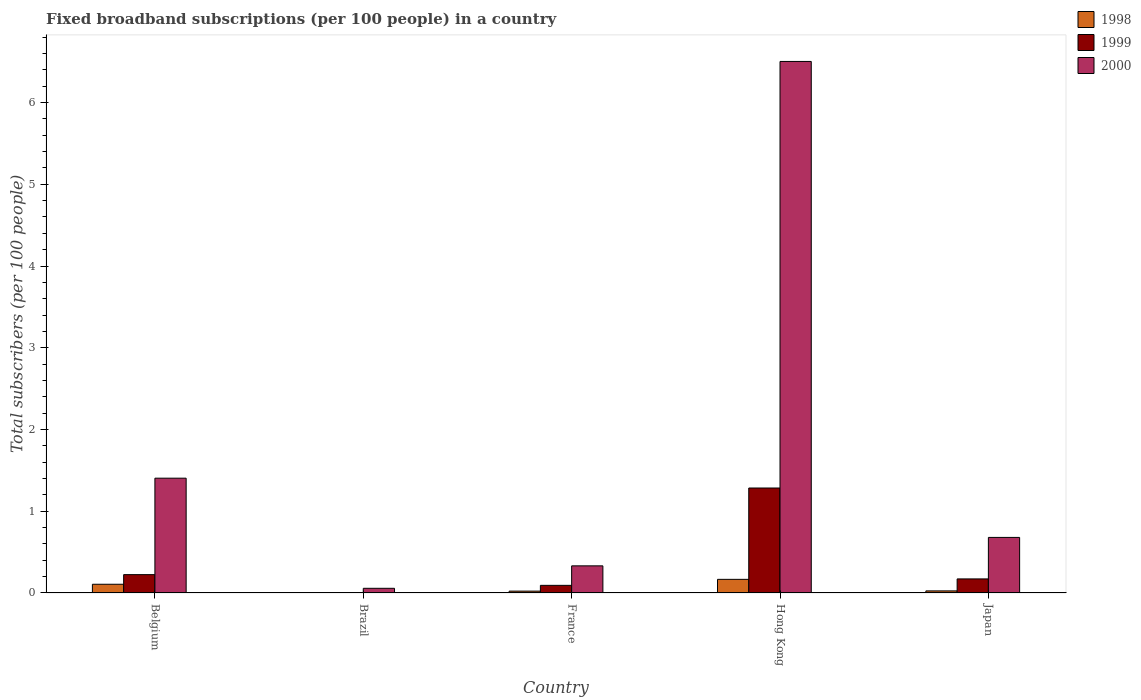Are the number of bars on each tick of the X-axis equal?
Your response must be concise. Yes. How many bars are there on the 2nd tick from the right?
Provide a short and direct response. 3. What is the label of the 4th group of bars from the left?
Provide a succinct answer. Hong Kong. What is the number of broadband subscriptions in 1999 in Brazil?
Make the answer very short. 0. Across all countries, what is the maximum number of broadband subscriptions in 2000?
Ensure brevity in your answer.  6.5. Across all countries, what is the minimum number of broadband subscriptions in 1999?
Keep it short and to the point. 0. In which country was the number of broadband subscriptions in 2000 maximum?
Keep it short and to the point. Hong Kong. What is the total number of broadband subscriptions in 1999 in the graph?
Offer a terse response. 1.78. What is the difference between the number of broadband subscriptions in 2000 in Belgium and that in Brazil?
Your answer should be compact. 1.35. What is the difference between the number of broadband subscriptions in 1998 in Brazil and the number of broadband subscriptions in 2000 in Hong Kong?
Keep it short and to the point. -6.5. What is the average number of broadband subscriptions in 1999 per country?
Offer a terse response. 0.36. What is the difference between the number of broadband subscriptions of/in 1999 and number of broadband subscriptions of/in 2000 in Japan?
Keep it short and to the point. -0.51. What is the ratio of the number of broadband subscriptions in 1999 in Belgium to that in France?
Your answer should be very brief. 2.4. What is the difference between the highest and the second highest number of broadband subscriptions in 1998?
Provide a short and direct response. 0.06. What is the difference between the highest and the lowest number of broadband subscriptions in 1999?
Your response must be concise. 1.28. In how many countries, is the number of broadband subscriptions in 1998 greater than the average number of broadband subscriptions in 1998 taken over all countries?
Make the answer very short. 2. Is the sum of the number of broadband subscriptions in 1999 in France and Hong Kong greater than the maximum number of broadband subscriptions in 2000 across all countries?
Give a very brief answer. No. What does the 1st bar from the right in Brazil represents?
Provide a succinct answer. 2000. How many bars are there?
Your answer should be very brief. 15. Are all the bars in the graph horizontal?
Offer a very short reply. No. How many countries are there in the graph?
Give a very brief answer. 5. What is the difference between two consecutive major ticks on the Y-axis?
Make the answer very short. 1. Does the graph contain any zero values?
Make the answer very short. No. Does the graph contain grids?
Make the answer very short. No. How many legend labels are there?
Make the answer very short. 3. What is the title of the graph?
Ensure brevity in your answer.  Fixed broadband subscriptions (per 100 people) in a country. What is the label or title of the Y-axis?
Keep it short and to the point. Total subscribers (per 100 people). What is the Total subscribers (per 100 people) in 1998 in Belgium?
Your answer should be compact. 0.11. What is the Total subscribers (per 100 people) of 1999 in Belgium?
Your answer should be compact. 0.22. What is the Total subscribers (per 100 people) in 2000 in Belgium?
Give a very brief answer. 1.4. What is the Total subscribers (per 100 people) in 1998 in Brazil?
Make the answer very short. 0. What is the Total subscribers (per 100 people) in 1999 in Brazil?
Your answer should be very brief. 0. What is the Total subscribers (per 100 people) of 2000 in Brazil?
Make the answer very short. 0.06. What is the Total subscribers (per 100 people) in 1998 in France?
Your response must be concise. 0.02. What is the Total subscribers (per 100 people) of 1999 in France?
Keep it short and to the point. 0.09. What is the Total subscribers (per 100 people) in 2000 in France?
Offer a terse response. 0.33. What is the Total subscribers (per 100 people) in 1998 in Hong Kong?
Your answer should be very brief. 0.17. What is the Total subscribers (per 100 people) in 1999 in Hong Kong?
Ensure brevity in your answer.  1.28. What is the Total subscribers (per 100 people) of 2000 in Hong Kong?
Provide a succinct answer. 6.5. What is the Total subscribers (per 100 people) of 1998 in Japan?
Offer a very short reply. 0.03. What is the Total subscribers (per 100 people) of 1999 in Japan?
Keep it short and to the point. 0.17. What is the Total subscribers (per 100 people) in 2000 in Japan?
Your response must be concise. 0.68. Across all countries, what is the maximum Total subscribers (per 100 people) of 1998?
Ensure brevity in your answer.  0.17. Across all countries, what is the maximum Total subscribers (per 100 people) in 1999?
Your answer should be very brief. 1.28. Across all countries, what is the maximum Total subscribers (per 100 people) of 2000?
Ensure brevity in your answer.  6.5. Across all countries, what is the minimum Total subscribers (per 100 people) of 1998?
Your response must be concise. 0. Across all countries, what is the minimum Total subscribers (per 100 people) in 1999?
Your answer should be compact. 0. Across all countries, what is the minimum Total subscribers (per 100 people) of 2000?
Your response must be concise. 0.06. What is the total Total subscribers (per 100 people) in 1998 in the graph?
Offer a terse response. 0.32. What is the total Total subscribers (per 100 people) in 1999 in the graph?
Provide a short and direct response. 1.78. What is the total Total subscribers (per 100 people) in 2000 in the graph?
Your answer should be very brief. 8.98. What is the difference between the Total subscribers (per 100 people) of 1998 in Belgium and that in Brazil?
Offer a terse response. 0.11. What is the difference between the Total subscribers (per 100 people) of 1999 in Belgium and that in Brazil?
Provide a succinct answer. 0.22. What is the difference between the Total subscribers (per 100 people) of 2000 in Belgium and that in Brazil?
Keep it short and to the point. 1.35. What is the difference between the Total subscribers (per 100 people) in 1998 in Belgium and that in France?
Offer a terse response. 0.08. What is the difference between the Total subscribers (per 100 people) of 1999 in Belgium and that in France?
Offer a very short reply. 0.13. What is the difference between the Total subscribers (per 100 people) of 2000 in Belgium and that in France?
Give a very brief answer. 1.07. What is the difference between the Total subscribers (per 100 people) in 1998 in Belgium and that in Hong Kong?
Your answer should be very brief. -0.06. What is the difference between the Total subscribers (per 100 people) in 1999 in Belgium and that in Hong Kong?
Give a very brief answer. -1.06. What is the difference between the Total subscribers (per 100 people) of 2000 in Belgium and that in Hong Kong?
Provide a short and direct response. -5.1. What is the difference between the Total subscribers (per 100 people) in 1998 in Belgium and that in Japan?
Offer a terse response. 0.08. What is the difference between the Total subscribers (per 100 people) in 1999 in Belgium and that in Japan?
Ensure brevity in your answer.  0.05. What is the difference between the Total subscribers (per 100 people) in 2000 in Belgium and that in Japan?
Your answer should be compact. 0.72. What is the difference between the Total subscribers (per 100 people) in 1998 in Brazil and that in France?
Give a very brief answer. -0.02. What is the difference between the Total subscribers (per 100 people) of 1999 in Brazil and that in France?
Make the answer very short. -0.09. What is the difference between the Total subscribers (per 100 people) of 2000 in Brazil and that in France?
Offer a terse response. -0.27. What is the difference between the Total subscribers (per 100 people) of 1998 in Brazil and that in Hong Kong?
Provide a succinct answer. -0.17. What is the difference between the Total subscribers (per 100 people) in 1999 in Brazil and that in Hong Kong?
Keep it short and to the point. -1.28. What is the difference between the Total subscribers (per 100 people) in 2000 in Brazil and that in Hong Kong?
Keep it short and to the point. -6.45. What is the difference between the Total subscribers (per 100 people) in 1998 in Brazil and that in Japan?
Your answer should be compact. -0.03. What is the difference between the Total subscribers (per 100 people) in 1999 in Brazil and that in Japan?
Make the answer very short. -0.17. What is the difference between the Total subscribers (per 100 people) of 2000 in Brazil and that in Japan?
Offer a terse response. -0.62. What is the difference between the Total subscribers (per 100 people) of 1998 in France and that in Hong Kong?
Give a very brief answer. -0.14. What is the difference between the Total subscribers (per 100 people) of 1999 in France and that in Hong Kong?
Give a very brief answer. -1.19. What is the difference between the Total subscribers (per 100 people) in 2000 in France and that in Hong Kong?
Your answer should be compact. -6.17. What is the difference between the Total subscribers (per 100 people) in 1998 in France and that in Japan?
Your answer should be compact. -0. What is the difference between the Total subscribers (per 100 people) in 1999 in France and that in Japan?
Your response must be concise. -0.08. What is the difference between the Total subscribers (per 100 people) in 2000 in France and that in Japan?
Provide a succinct answer. -0.35. What is the difference between the Total subscribers (per 100 people) in 1998 in Hong Kong and that in Japan?
Keep it short and to the point. 0.14. What is the difference between the Total subscribers (per 100 people) in 1999 in Hong Kong and that in Japan?
Provide a succinct answer. 1.11. What is the difference between the Total subscribers (per 100 people) in 2000 in Hong Kong and that in Japan?
Your answer should be very brief. 5.82. What is the difference between the Total subscribers (per 100 people) of 1998 in Belgium and the Total subscribers (per 100 people) of 1999 in Brazil?
Your answer should be very brief. 0.1. What is the difference between the Total subscribers (per 100 people) in 1998 in Belgium and the Total subscribers (per 100 people) in 2000 in Brazil?
Your answer should be very brief. 0.05. What is the difference between the Total subscribers (per 100 people) in 1999 in Belgium and the Total subscribers (per 100 people) in 2000 in Brazil?
Your answer should be compact. 0.17. What is the difference between the Total subscribers (per 100 people) in 1998 in Belgium and the Total subscribers (per 100 people) in 1999 in France?
Your response must be concise. 0.01. What is the difference between the Total subscribers (per 100 people) of 1998 in Belgium and the Total subscribers (per 100 people) of 2000 in France?
Keep it short and to the point. -0.23. What is the difference between the Total subscribers (per 100 people) in 1999 in Belgium and the Total subscribers (per 100 people) in 2000 in France?
Offer a very short reply. -0.11. What is the difference between the Total subscribers (per 100 people) in 1998 in Belgium and the Total subscribers (per 100 people) in 1999 in Hong Kong?
Provide a succinct answer. -1.18. What is the difference between the Total subscribers (per 100 people) in 1998 in Belgium and the Total subscribers (per 100 people) in 2000 in Hong Kong?
Your answer should be compact. -6.4. What is the difference between the Total subscribers (per 100 people) of 1999 in Belgium and the Total subscribers (per 100 people) of 2000 in Hong Kong?
Offer a very short reply. -6.28. What is the difference between the Total subscribers (per 100 people) of 1998 in Belgium and the Total subscribers (per 100 people) of 1999 in Japan?
Offer a very short reply. -0.07. What is the difference between the Total subscribers (per 100 people) in 1998 in Belgium and the Total subscribers (per 100 people) in 2000 in Japan?
Offer a terse response. -0.57. What is the difference between the Total subscribers (per 100 people) in 1999 in Belgium and the Total subscribers (per 100 people) in 2000 in Japan?
Your answer should be very brief. -0.46. What is the difference between the Total subscribers (per 100 people) in 1998 in Brazil and the Total subscribers (per 100 people) in 1999 in France?
Make the answer very short. -0.09. What is the difference between the Total subscribers (per 100 people) of 1998 in Brazil and the Total subscribers (per 100 people) of 2000 in France?
Your answer should be very brief. -0.33. What is the difference between the Total subscribers (per 100 people) of 1999 in Brazil and the Total subscribers (per 100 people) of 2000 in France?
Your response must be concise. -0.33. What is the difference between the Total subscribers (per 100 people) of 1998 in Brazil and the Total subscribers (per 100 people) of 1999 in Hong Kong?
Your response must be concise. -1.28. What is the difference between the Total subscribers (per 100 people) in 1998 in Brazil and the Total subscribers (per 100 people) in 2000 in Hong Kong?
Offer a terse response. -6.5. What is the difference between the Total subscribers (per 100 people) in 1999 in Brazil and the Total subscribers (per 100 people) in 2000 in Hong Kong?
Your answer should be very brief. -6.5. What is the difference between the Total subscribers (per 100 people) of 1998 in Brazil and the Total subscribers (per 100 people) of 1999 in Japan?
Provide a succinct answer. -0.17. What is the difference between the Total subscribers (per 100 people) in 1998 in Brazil and the Total subscribers (per 100 people) in 2000 in Japan?
Offer a terse response. -0.68. What is the difference between the Total subscribers (per 100 people) of 1999 in Brazil and the Total subscribers (per 100 people) of 2000 in Japan?
Offer a very short reply. -0.68. What is the difference between the Total subscribers (per 100 people) in 1998 in France and the Total subscribers (per 100 people) in 1999 in Hong Kong?
Make the answer very short. -1.26. What is the difference between the Total subscribers (per 100 people) in 1998 in France and the Total subscribers (per 100 people) in 2000 in Hong Kong?
Give a very brief answer. -6.48. What is the difference between the Total subscribers (per 100 people) of 1999 in France and the Total subscribers (per 100 people) of 2000 in Hong Kong?
Provide a succinct answer. -6.41. What is the difference between the Total subscribers (per 100 people) in 1998 in France and the Total subscribers (per 100 people) in 1999 in Japan?
Offer a terse response. -0.15. What is the difference between the Total subscribers (per 100 people) in 1998 in France and the Total subscribers (per 100 people) in 2000 in Japan?
Offer a very short reply. -0.66. What is the difference between the Total subscribers (per 100 people) in 1999 in France and the Total subscribers (per 100 people) in 2000 in Japan?
Offer a terse response. -0.59. What is the difference between the Total subscribers (per 100 people) of 1998 in Hong Kong and the Total subscribers (per 100 people) of 1999 in Japan?
Keep it short and to the point. -0.01. What is the difference between the Total subscribers (per 100 people) in 1998 in Hong Kong and the Total subscribers (per 100 people) in 2000 in Japan?
Provide a short and direct response. -0.51. What is the difference between the Total subscribers (per 100 people) of 1999 in Hong Kong and the Total subscribers (per 100 people) of 2000 in Japan?
Offer a very short reply. 0.6. What is the average Total subscribers (per 100 people) of 1998 per country?
Make the answer very short. 0.06. What is the average Total subscribers (per 100 people) in 1999 per country?
Provide a short and direct response. 0.36. What is the average Total subscribers (per 100 people) of 2000 per country?
Your answer should be compact. 1.8. What is the difference between the Total subscribers (per 100 people) of 1998 and Total subscribers (per 100 people) of 1999 in Belgium?
Keep it short and to the point. -0.12. What is the difference between the Total subscribers (per 100 people) in 1998 and Total subscribers (per 100 people) in 2000 in Belgium?
Give a very brief answer. -1.3. What is the difference between the Total subscribers (per 100 people) in 1999 and Total subscribers (per 100 people) in 2000 in Belgium?
Give a very brief answer. -1.18. What is the difference between the Total subscribers (per 100 people) in 1998 and Total subscribers (per 100 people) in 1999 in Brazil?
Provide a short and direct response. -0. What is the difference between the Total subscribers (per 100 people) in 1998 and Total subscribers (per 100 people) in 2000 in Brazil?
Give a very brief answer. -0.06. What is the difference between the Total subscribers (per 100 people) of 1999 and Total subscribers (per 100 people) of 2000 in Brazil?
Your response must be concise. -0.05. What is the difference between the Total subscribers (per 100 people) in 1998 and Total subscribers (per 100 people) in 1999 in France?
Your answer should be compact. -0.07. What is the difference between the Total subscribers (per 100 people) in 1998 and Total subscribers (per 100 people) in 2000 in France?
Your answer should be very brief. -0.31. What is the difference between the Total subscribers (per 100 people) of 1999 and Total subscribers (per 100 people) of 2000 in France?
Offer a terse response. -0.24. What is the difference between the Total subscribers (per 100 people) of 1998 and Total subscribers (per 100 people) of 1999 in Hong Kong?
Give a very brief answer. -1.12. What is the difference between the Total subscribers (per 100 people) of 1998 and Total subscribers (per 100 people) of 2000 in Hong Kong?
Keep it short and to the point. -6.34. What is the difference between the Total subscribers (per 100 people) of 1999 and Total subscribers (per 100 people) of 2000 in Hong Kong?
Give a very brief answer. -5.22. What is the difference between the Total subscribers (per 100 people) of 1998 and Total subscribers (per 100 people) of 1999 in Japan?
Give a very brief answer. -0.15. What is the difference between the Total subscribers (per 100 people) in 1998 and Total subscribers (per 100 people) in 2000 in Japan?
Provide a succinct answer. -0.65. What is the difference between the Total subscribers (per 100 people) in 1999 and Total subscribers (per 100 people) in 2000 in Japan?
Keep it short and to the point. -0.51. What is the ratio of the Total subscribers (per 100 people) of 1998 in Belgium to that in Brazil?
Your response must be concise. 181.1. What is the ratio of the Total subscribers (per 100 people) in 1999 in Belgium to that in Brazil?
Ensure brevity in your answer.  55.18. What is the ratio of the Total subscribers (per 100 people) of 2000 in Belgium to that in Brazil?
Your answer should be very brief. 24.51. What is the ratio of the Total subscribers (per 100 people) in 1998 in Belgium to that in France?
Provide a short and direct response. 4.65. What is the ratio of the Total subscribers (per 100 people) in 1999 in Belgium to that in France?
Give a very brief answer. 2.4. What is the ratio of the Total subscribers (per 100 people) of 2000 in Belgium to that in France?
Make the answer very short. 4.23. What is the ratio of the Total subscribers (per 100 people) in 1998 in Belgium to that in Hong Kong?
Keep it short and to the point. 0.64. What is the ratio of the Total subscribers (per 100 people) of 1999 in Belgium to that in Hong Kong?
Provide a succinct answer. 0.17. What is the ratio of the Total subscribers (per 100 people) in 2000 in Belgium to that in Hong Kong?
Offer a terse response. 0.22. What is the ratio of the Total subscribers (per 100 people) of 1998 in Belgium to that in Japan?
Your response must be concise. 4.18. What is the ratio of the Total subscribers (per 100 people) in 1999 in Belgium to that in Japan?
Ensure brevity in your answer.  1.3. What is the ratio of the Total subscribers (per 100 people) in 2000 in Belgium to that in Japan?
Give a very brief answer. 2.07. What is the ratio of the Total subscribers (per 100 people) in 1998 in Brazil to that in France?
Keep it short and to the point. 0.03. What is the ratio of the Total subscribers (per 100 people) in 1999 in Brazil to that in France?
Provide a short and direct response. 0.04. What is the ratio of the Total subscribers (per 100 people) in 2000 in Brazil to that in France?
Give a very brief answer. 0.17. What is the ratio of the Total subscribers (per 100 people) in 1998 in Brazil to that in Hong Kong?
Offer a very short reply. 0. What is the ratio of the Total subscribers (per 100 people) in 1999 in Brazil to that in Hong Kong?
Your answer should be very brief. 0. What is the ratio of the Total subscribers (per 100 people) in 2000 in Brazil to that in Hong Kong?
Offer a very short reply. 0.01. What is the ratio of the Total subscribers (per 100 people) of 1998 in Brazil to that in Japan?
Provide a short and direct response. 0.02. What is the ratio of the Total subscribers (per 100 people) in 1999 in Brazil to that in Japan?
Keep it short and to the point. 0.02. What is the ratio of the Total subscribers (per 100 people) of 2000 in Brazil to that in Japan?
Your answer should be very brief. 0.08. What is the ratio of the Total subscribers (per 100 people) in 1998 in France to that in Hong Kong?
Ensure brevity in your answer.  0.14. What is the ratio of the Total subscribers (per 100 people) in 1999 in France to that in Hong Kong?
Offer a terse response. 0.07. What is the ratio of the Total subscribers (per 100 people) in 2000 in France to that in Hong Kong?
Make the answer very short. 0.05. What is the ratio of the Total subscribers (per 100 people) in 1998 in France to that in Japan?
Provide a short and direct response. 0.9. What is the ratio of the Total subscribers (per 100 people) of 1999 in France to that in Japan?
Ensure brevity in your answer.  0.54. What is the ratio of the Total subscribers (per 100 people) of 2000 in France to that in Japan?
Provide a short and direct response. 0.49. What is the ratio of the Total subscribers (per 100 people) in 1998 in Hong Kong to that in Japan?
Offer a terse response. 6.53. What is the ratio of the Total subscribers (per 100 people) of 1999 in Hong Kong to that in Japan?
Your response must be concise. 7.46. What is the ratio of the Total subscribers (per 100 people) of 2000 in Hong Kong to that in Japan?
Your answer should be very brief. 9.56. What is the difference between the highest and the second highest Total subscribers (per 100 people) in 1999?
Give a very brief answer. 1.06. What is the difference between the highest and the second highest Total subscribers (per 100 people) of 2000?
Your response must be concise. 5.1. What is the difference between the highest and the lowest Total subscribers (per 100 people) in 1998?
Your answer should be very brief. 0.17. What is the difference between the highest and the lowest Total subscribers (per 100 people) in 1999?
Make the answer very short. 1.28. What is the difference between the highest and the lowest Total subscribers (per 100 people) in 2000?
Provide a short and direct response. 6.45. 